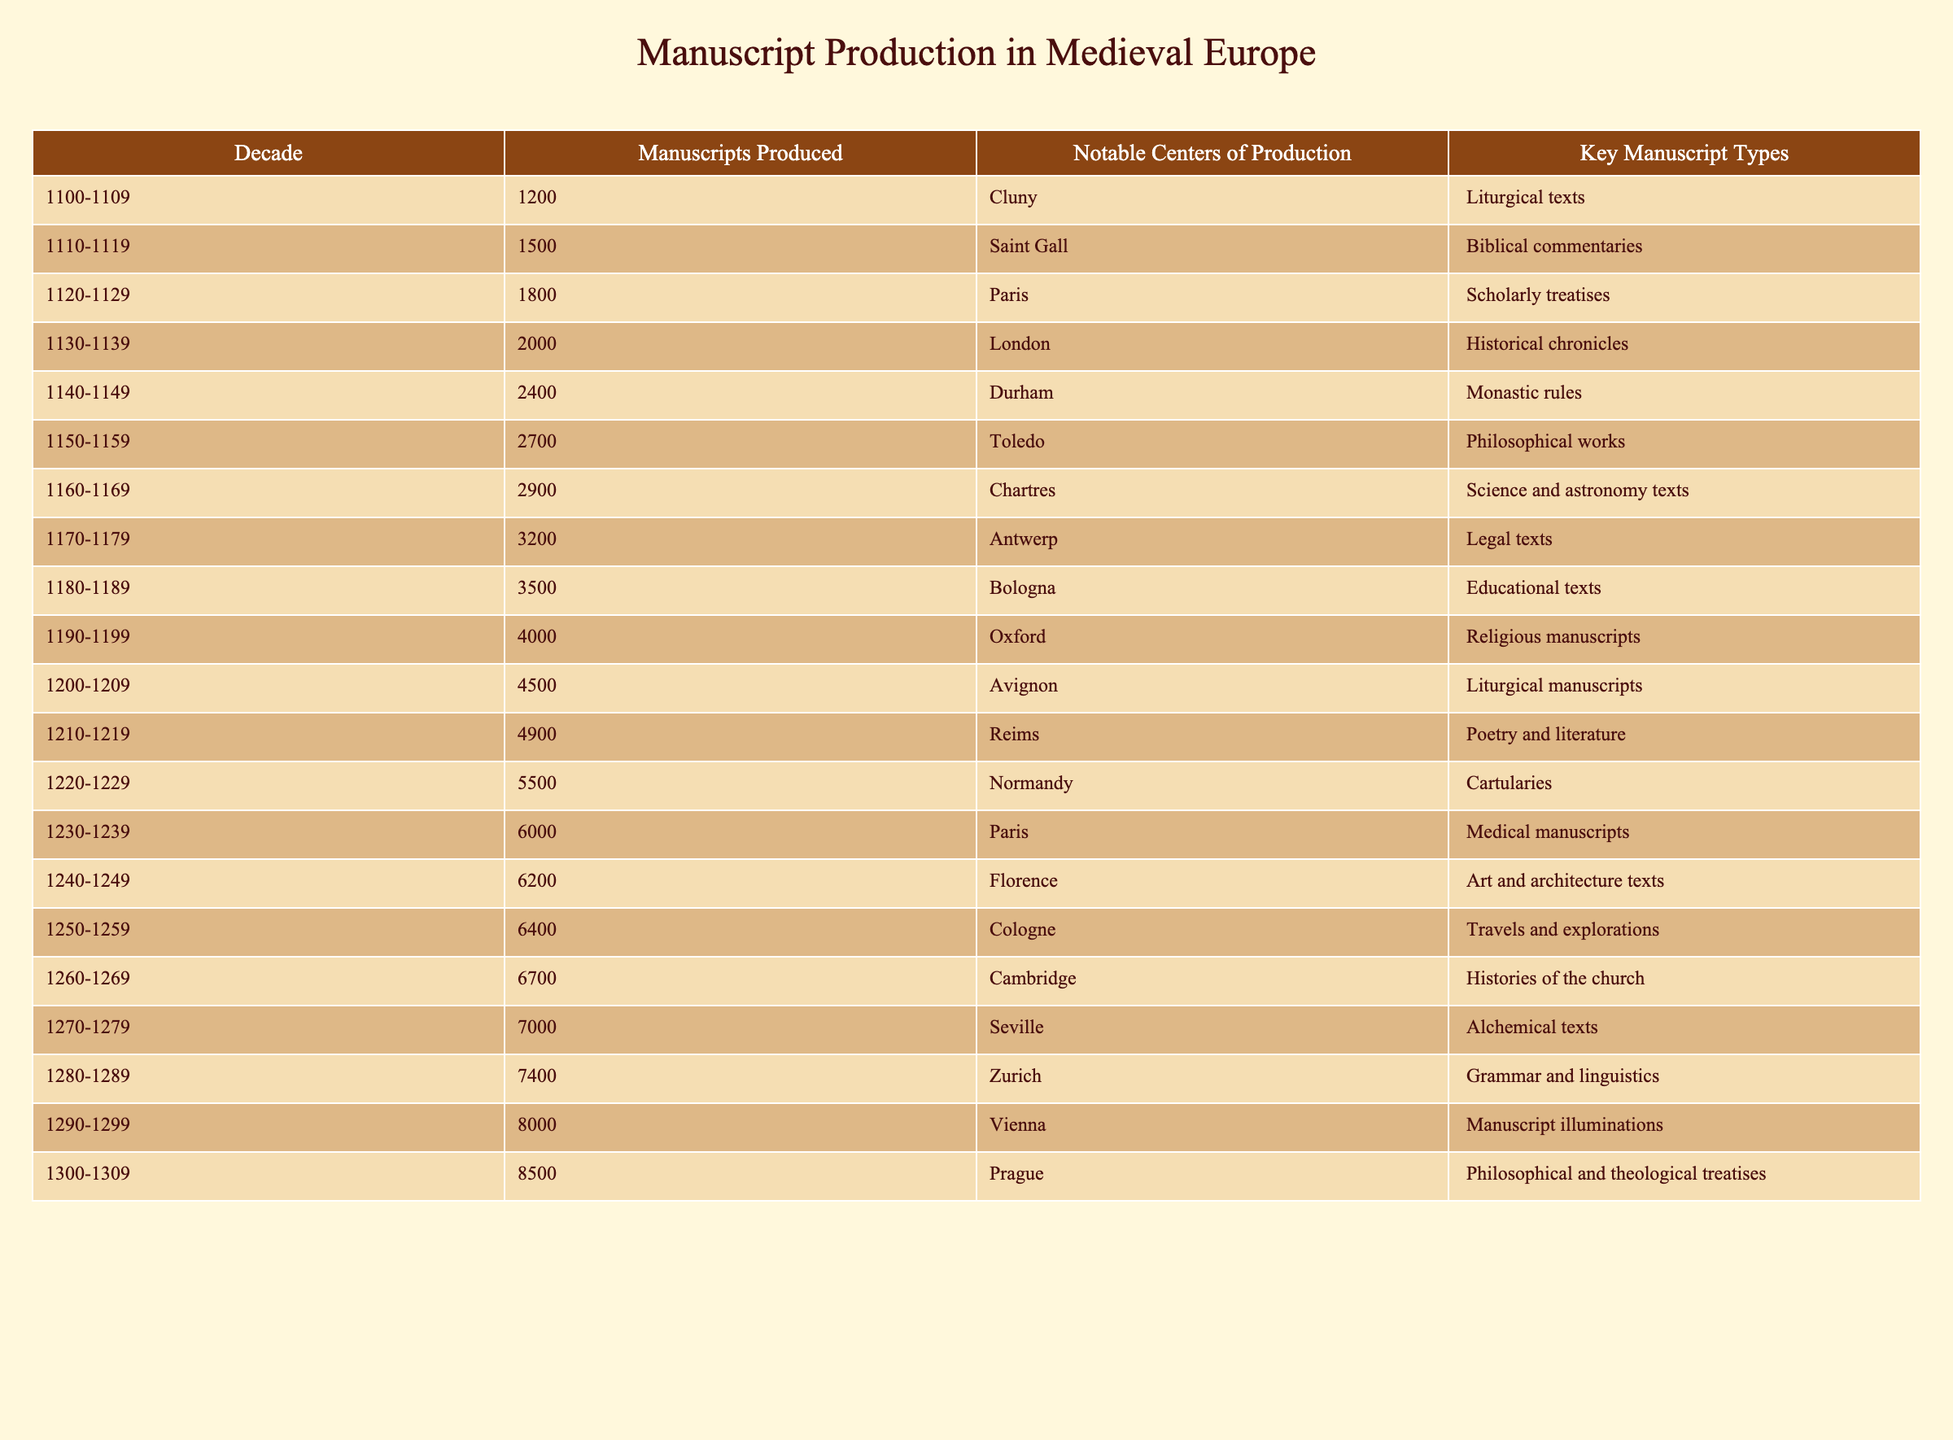What decade saw the highest production of manuscripts? From the table, the decade with the highest production of manuscripts is 1290-1299, which shows that 8000 manuscripts were produced.
Answer: 1290-1299 What was the total number of manuscripts produced from 1150-1159 to 1200-1209? To find the total, we sum the manuscripts produced in those decades: 2700 (1150-1159) + 2900 (1160-1169) + 3200 (1170-1179) + 3500 (1180-1189) + 4000 (1190-1199) + 4500 (1200-1209) = 18800.
Answer: 18800 In what notable center was the greatest number of manuscripts produced during the 1240-1249 decade? The table lists Florence as the notable center of production in the decade 1240-1249, where 6200 manuscripts were produced.
Answer: Florence Was the total number of manuscripts produced during the 1180-1189 decade more than the total for the 1160-1169 to 1170-1179 decades combined? The production from 1160-1169 is 2900 and from 1170-1179 is 3200, which sums to 6100. The production in the 1180-1189 decade is 3500, which is less than 6100. Thus, the statement is false.
Answer: No What key manuscript type was most commonly produced in the 1230-1239 decade? Referring to the table, the key manuscript type for the decade 1230-1239 is medical manuscripts.
Answer: Medical manuscripts Which decade produced the fewest manuscripts among the years provided? According to the table, the decade with the fewest manuscripts produced is 1100-1109, which had 1200 manuscripts.
Answer: 1100-1109 What is the average number of manuscripts produced for the decades from 1110-1119 to 1190-1199? To calculate the average, sum the manuscripts produced for those decades: 1500 + 1800 + 2000 + 2400 + 2700 + 2900 + 3500 + 4000 = 18800. There are 8 decades in total, so the average is 18800 / 8 = 2350.
Answer: 2350 How many manuscripts were produced in the notable center of Oxford during its peak production decade? The notable center of Oxford produced 4000 manuscripts during the decade 1190-1199, which is its peak.
Answer: 4000 What was the difference in manuscript production between the decades 1150-1159 and 1250-1259? The production in 1150-1159 was 2700 manuscripts, while in 1250-1259 it was 6400 manuscripts. The difference is 6400 - 2700 = 3700.
Answer: 3700 